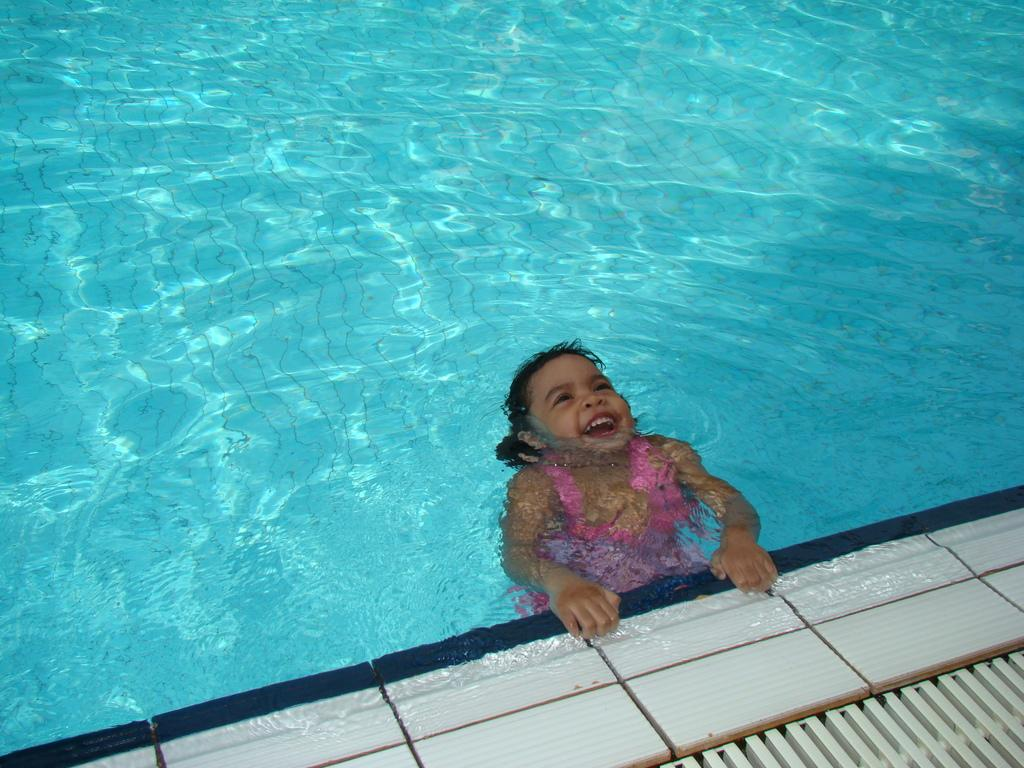What is the main feature of the image? The image contains a swimming pool. What is the girl in the foreground of the image doing? The girl is swimming in the foreground of the image. What is the girl's expression in the image? The girl is smiling. What type of material is used for the flooring in the foreground of the image? There are white tiles in the foreground of the image. What structure is present in the foreground of the image? There is an iron frame in the foreground of the image. What type of guide is present in the image to help the girl swim? There is no guide present in the image to help the girl swim; she appears to be swimming independently. Can you tell me how many scarecrows are visible in the image? There are no scarecrows present in the image. 